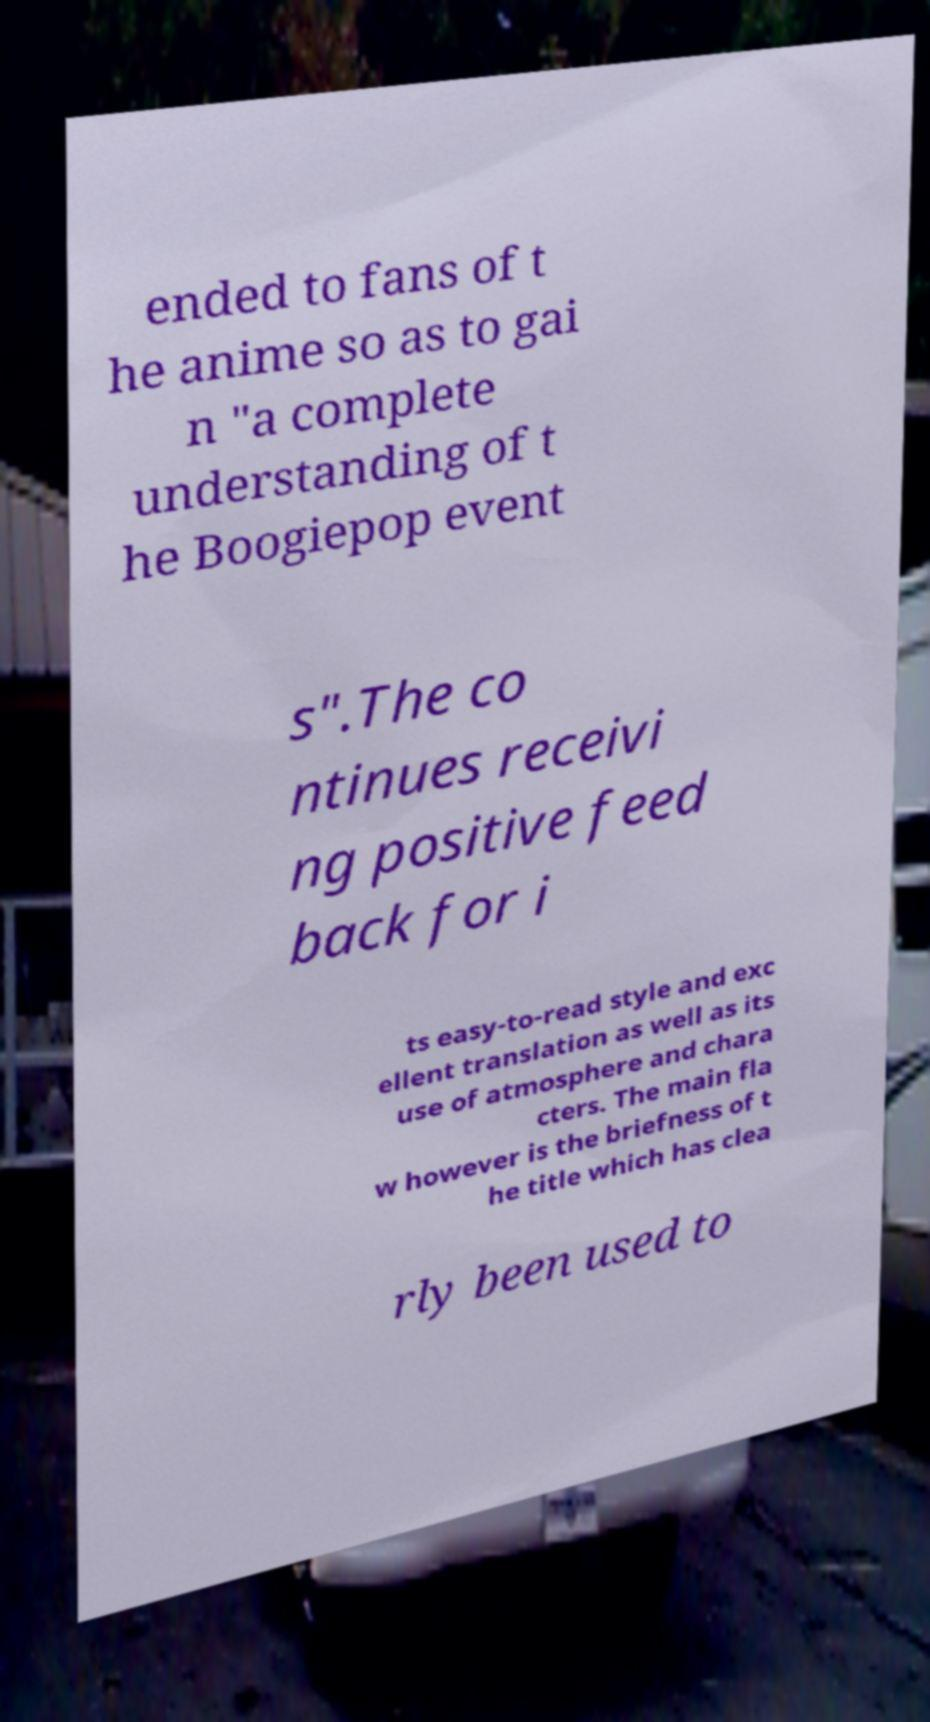Could you extract and type out the text from this image? ended to fans of t he anime so as to gai n "a complete understanding of t he Boogiepop event s".The co ntinues receivi ng positive feed back for i ts easy-to-read style and exc ellent translation as well as its use of atmosphere and chara cters. The main fla w however is the briefness of t he title which has clea rly been used to 